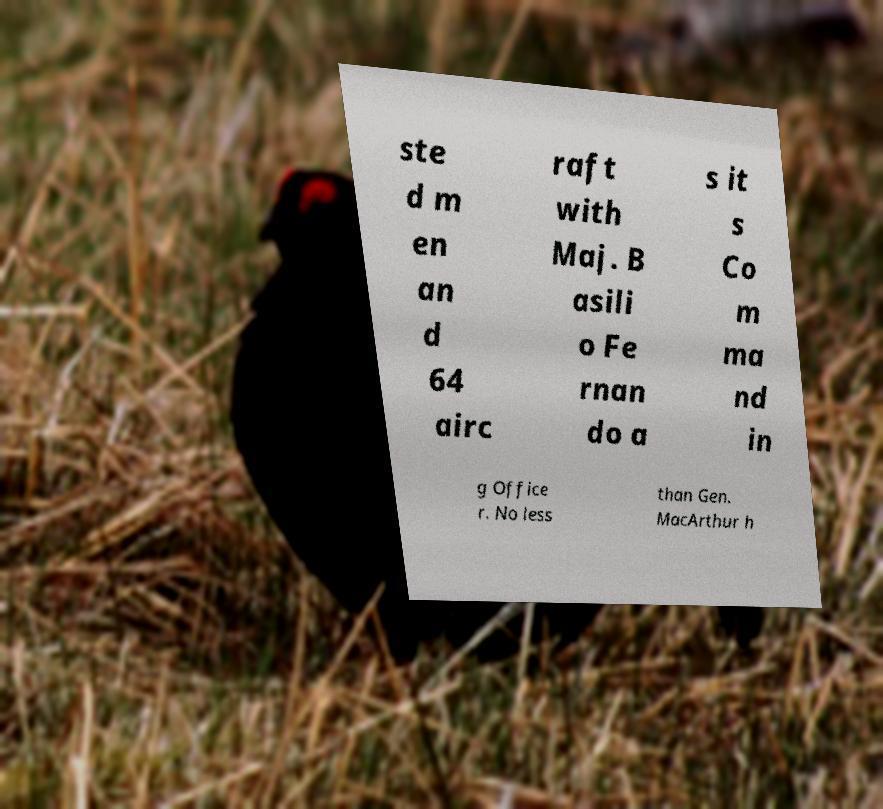For documentation purposes, I need the text within this image transcribed. Could you provide that? ste d m en an d 64 airc raft with Maj. B asili o Fe rnan do a s it s Co m ma nd in g Office r. No less than Gen. MacArthur h 